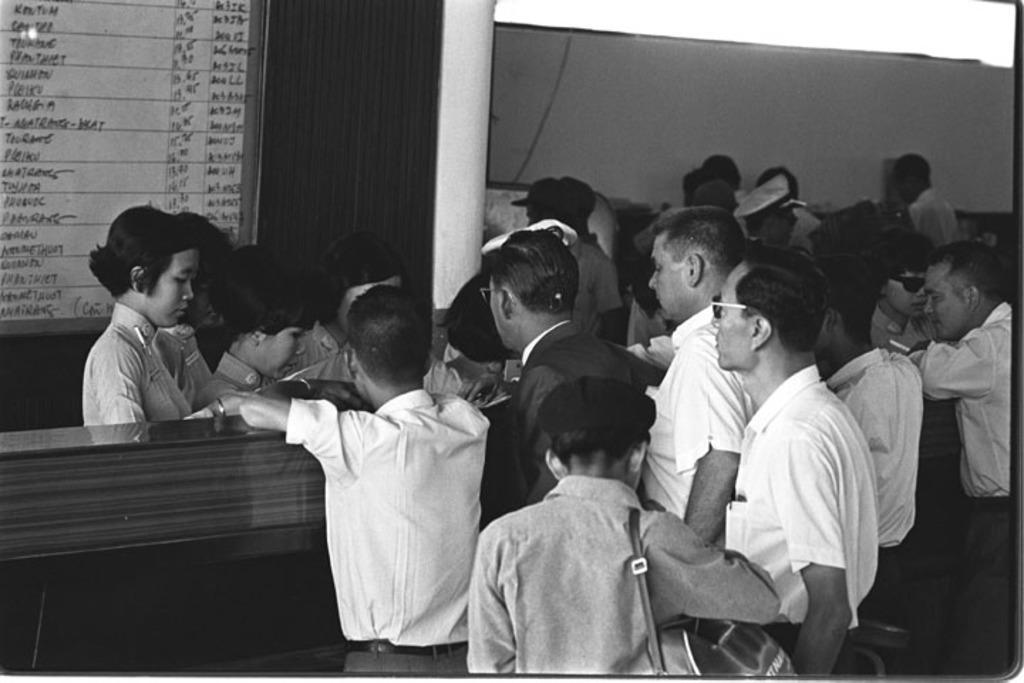Describe this image in one or two sentences. In this black and white picture there are people in the foreground, it seems like a board in the top left side. There is a desk and a pillar in front of them. 